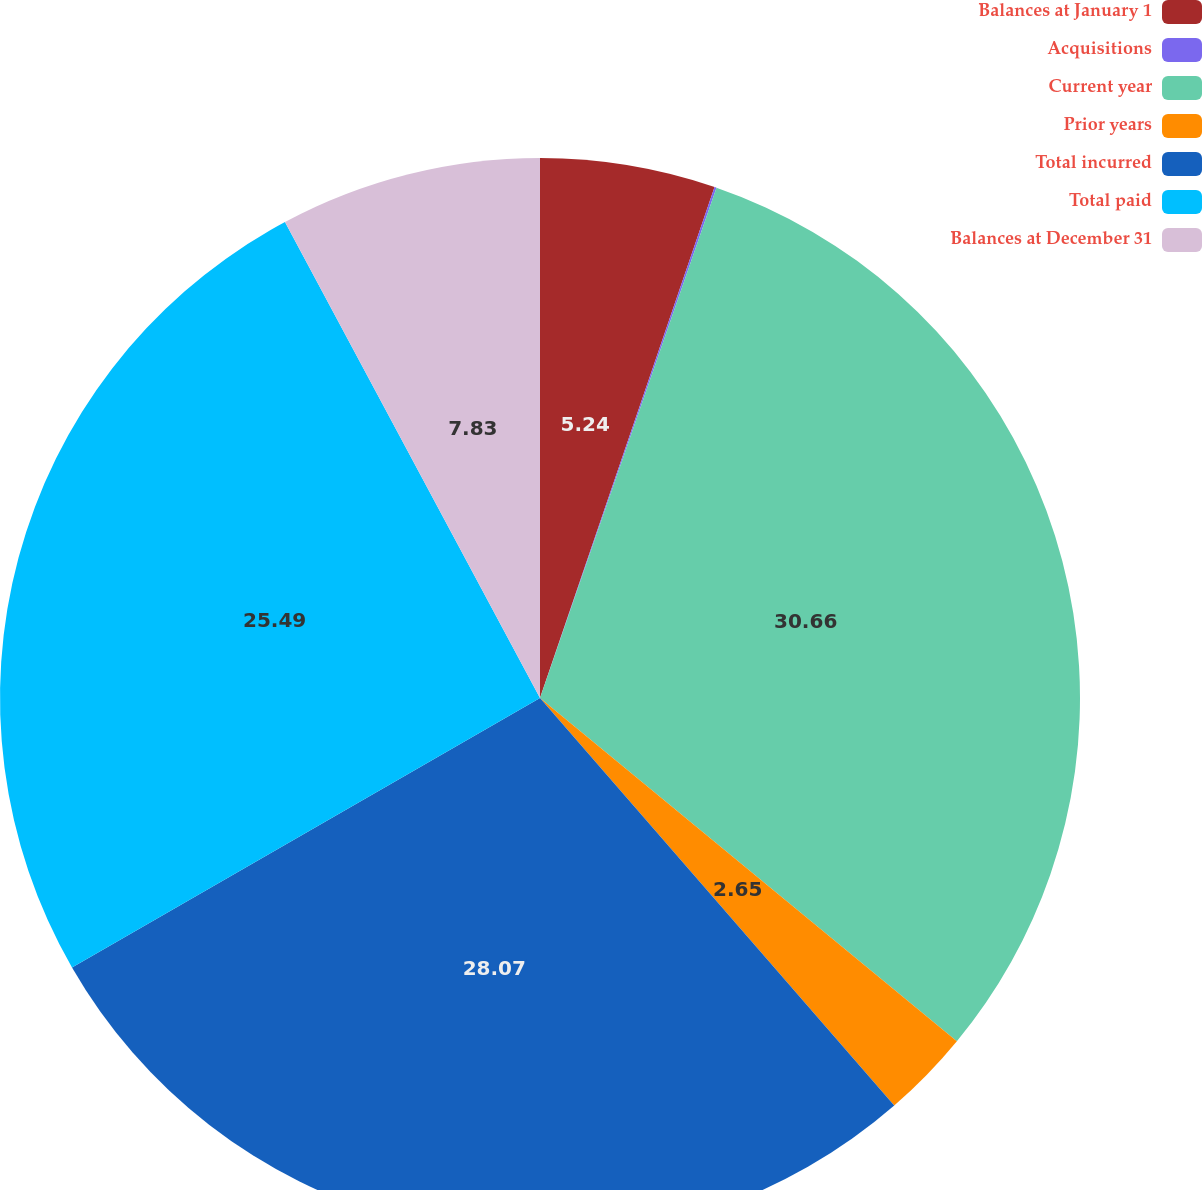Convert chart. <chart><loc_0><loc_0><loc_500><loc_500><pie_chart><fcel>Balances at January 1<fcel>Acquisitions<fcel>Current year<fcel>Prior years<fcel>Total incurred<fcel>Total paid<fcel>Balances at December 31<nl><fcel>5.24%<fcel>0.06%<fcel>30.67%<fcel>2.65%<fcel>28.08%<fcel>25.49%<fcel>7.83%<nl></chart> 